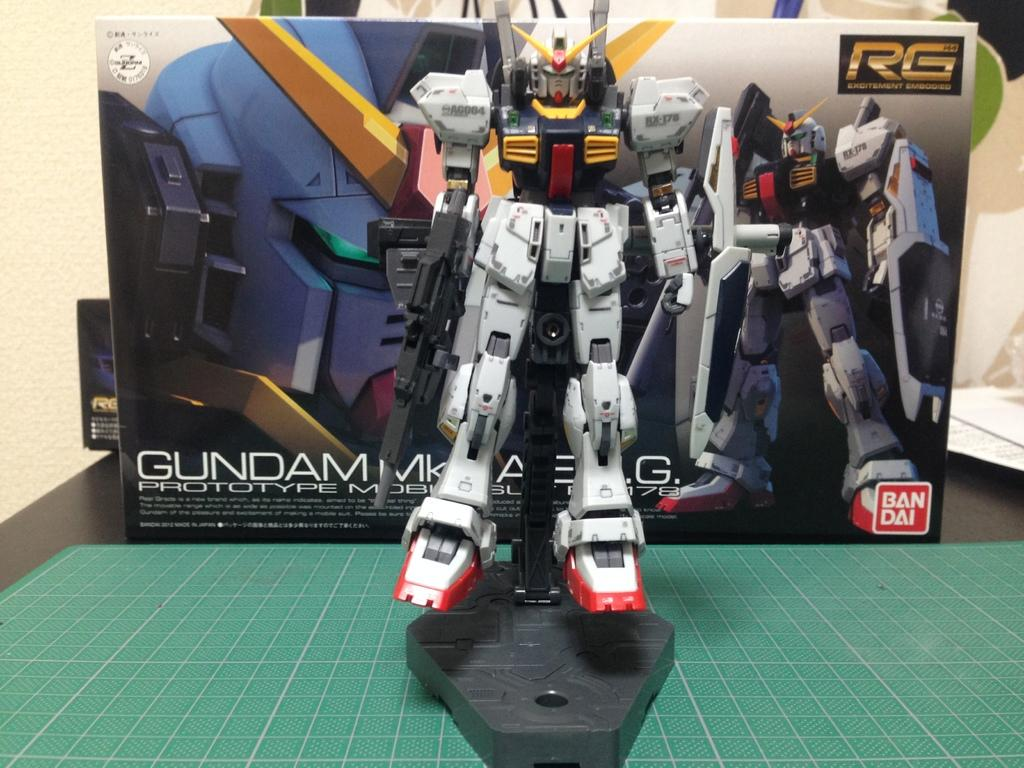What type of toy is in the image? There is a robot toy in the image. What colors can be seen on the robot toy? The robot toy is white, red, black, and yellow in color. What is the robot toy placed on? The robot toy is on a green colored object. What can be seen in the background of the image? There is a box and a cream-colored wall in the background of the image. What type of rhythm does the robot toy play in the image? There is no indication in the image that the robot toy plays any rhythm or music. 